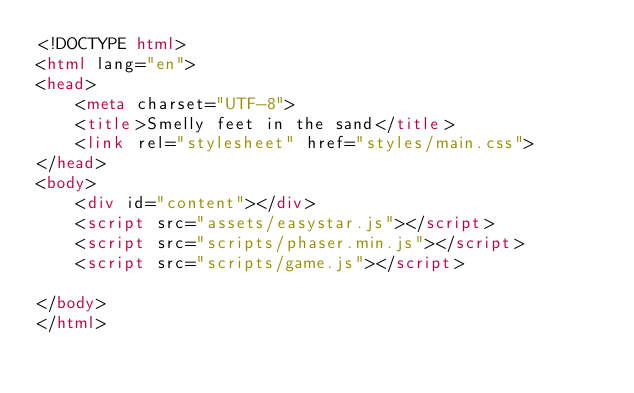<code> <loc_0><loc_0><loc_500><loc_500><_HTML_><!DOCTYPE html>
<html lang="en">
<head>
	<meta charset="UTF-8">
	<title>Smelly feet in the sand</title>
	<link rel="stylesheet" href="styles/main.css">
</head>
<body>
	<div id="content"></div>
	<script src="assets/easystar.js"></script>
	<script src="scripts/phaser.min.js"></script>
	<script src="scripts/game.js"></script>

</body>
</html></code> 